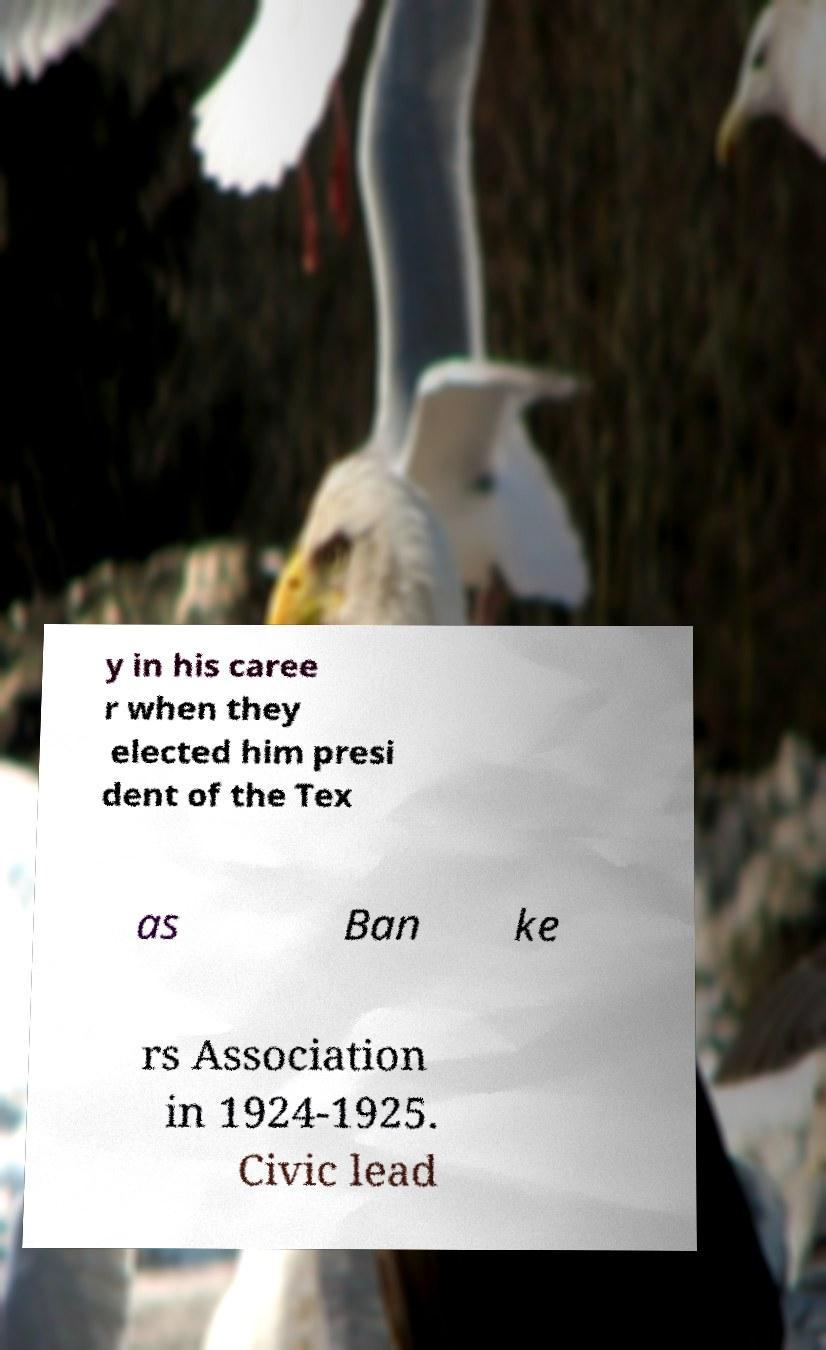Could you assist in decoding the text presented in this image and type it out clearly? y in his caree r when they elected him presi dent of the Tex as Ban ke rs Association in 1924-1925. Civic lead 